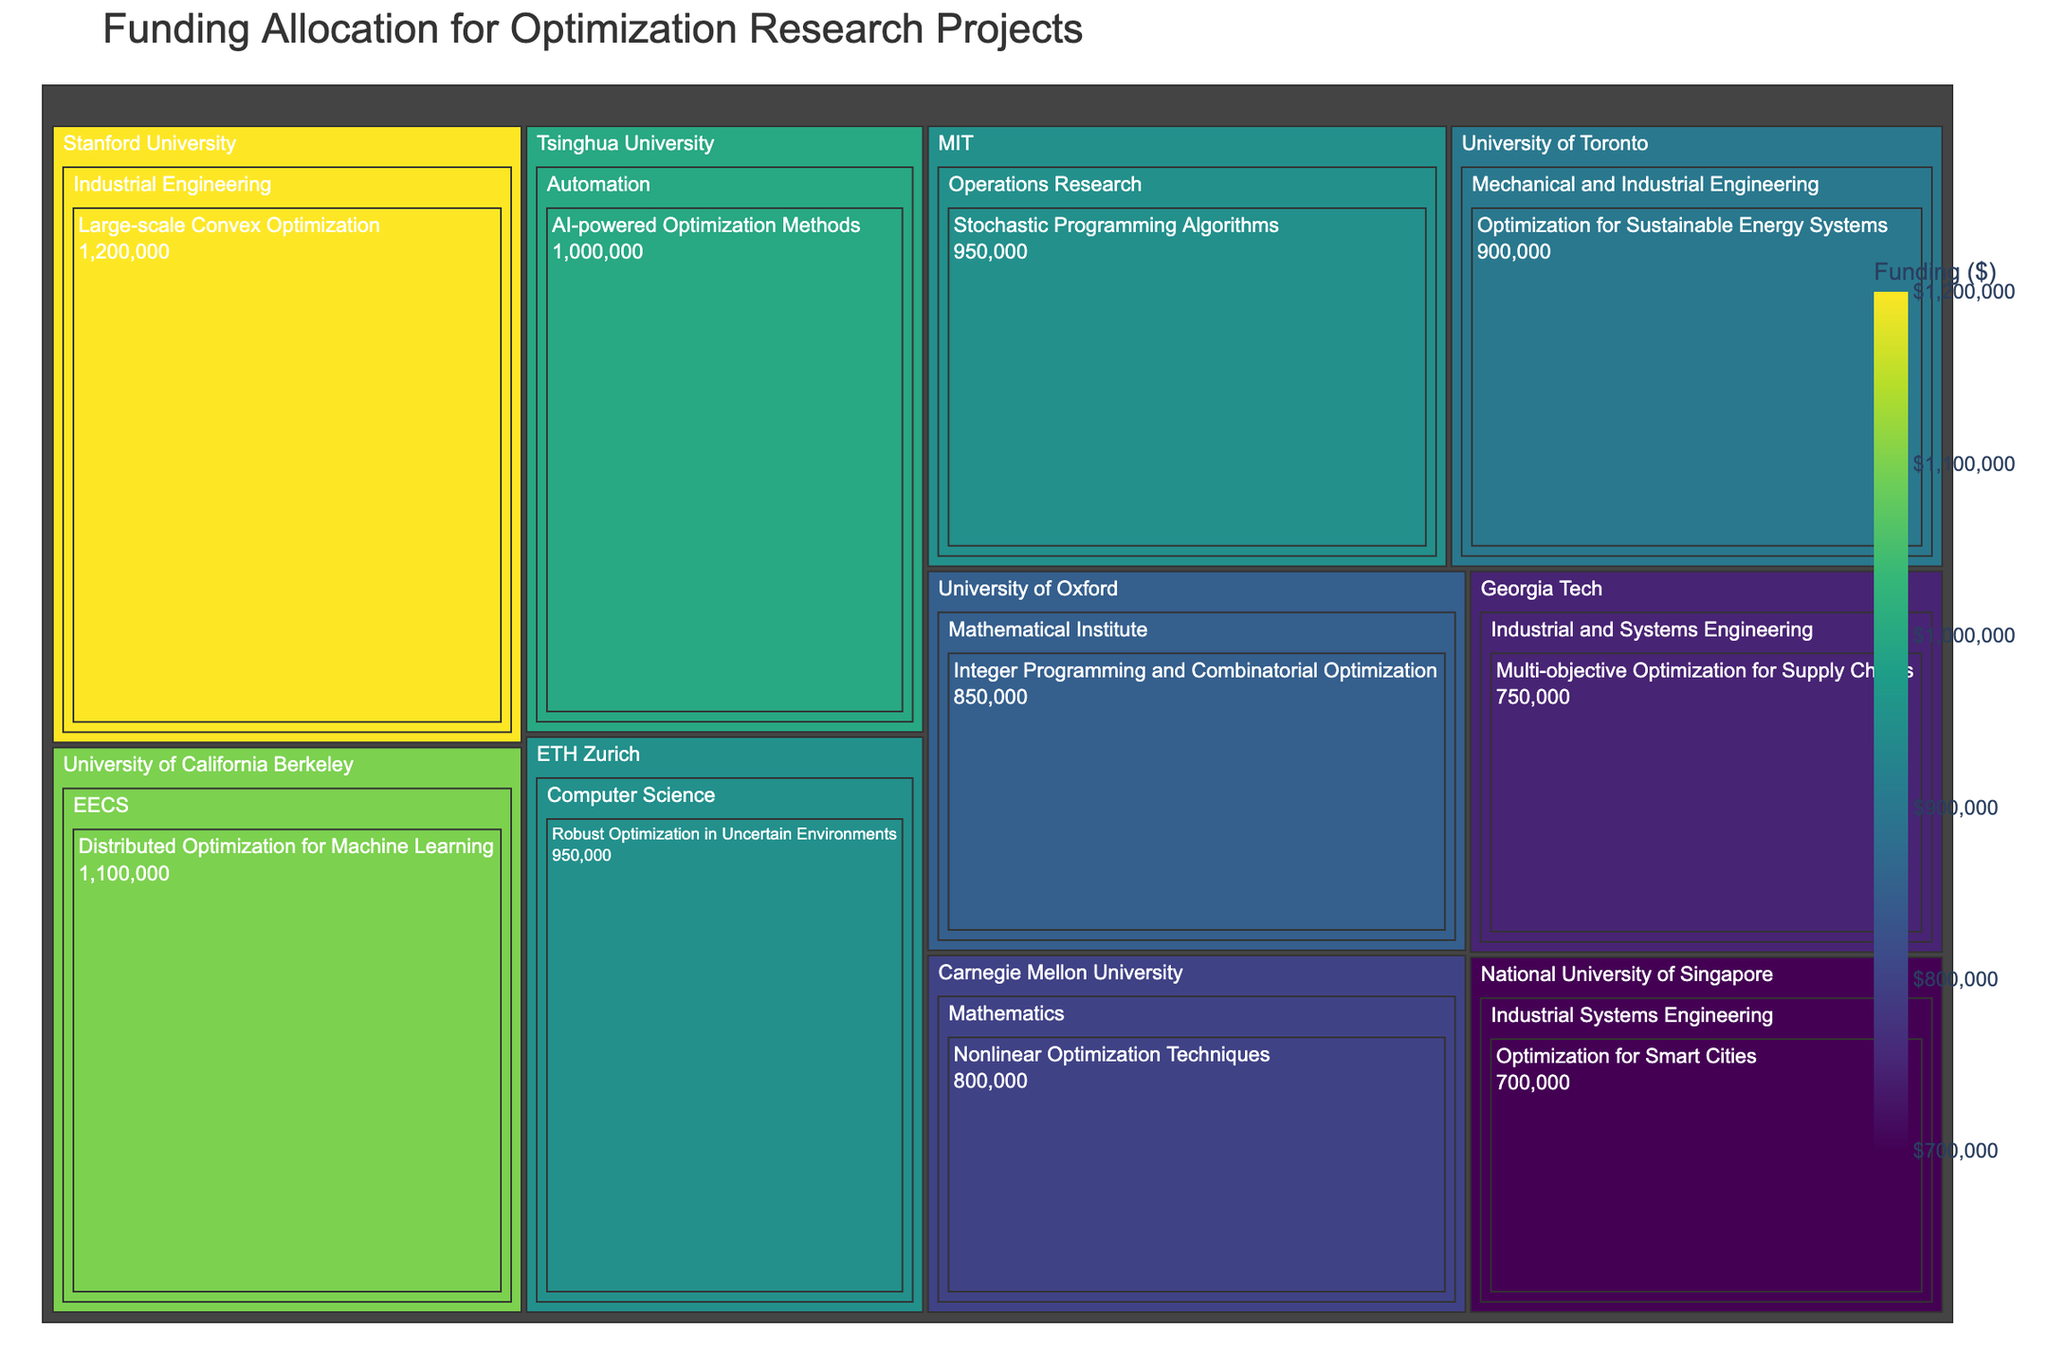What's the title of the figure? The title of the figure is usually prominently displayed at the top and provides a summary of the content. In this case, the title of the figure is "Funding Allocation for Optimization Research Projects".
Answer: Funding Allocation for Optimization Research Projects Which institution received the highest funding for its project? By observing the size and color intensity in the Treemap, we can see that Stanford University's "Large-scale Convex Optimization" project received the highest funding of $1,200,000, indicated by the largest and darkest section in the plot.
Answer: Stanford University What is the total funding allocated to the University of California Berkeley? To find the total funding for the University of California Berkeley, we look for the section labeled "University of California Berkeley" and sum up the funding amounts for its included projects. The only project listed is "Distributed Optimization for Machine Learning" with funding of $1,100,000.
Answer: $1,100,000 Which department at MIT has received funding, and for which project? The Treemap groups by institutions, then departments, followed by projects. At MIT, the department that received funding is "Operations Research" for the project "Stochastic Programming Algorithms".
Answer: Operations Research, Stochastic Programming Algorithms Compare the funding amounts between the institutions from Asia. To compare the funding amounts, we refer to the sections labeled for Asian institutions: National University of Singapore and Tsinghua University. The National University of Singapore received $700,000 for "Optimization for Smart Cities," whereas Tsinghua University received $1,000,000 for "AI-powered Optimization Methods". Tsinghua University received more funding.
Answer: Tsinghua University received more funding How does the funding for “Optimization for Sustainable Energy Systems” compare with “Optimization for Smart Cities”? To compare these two projects, we look at their corresponding sections in the Treemap. "Optimization for Sustainable Energy Systems" (University of Toronto) received $900,000, while "Optimization for Smart Cities" (National University of Singapore) received $700,000. Therefore, "Optimization for Sustainable Energy Systems" received more funding.
Answer: $900,000 vs. $700,000 What is the combined total funding for projects related to "Optimization for Machine Learning"? Searching the Treemap, the related project is "Distributed Optimization for Machine Learning" at University of California Berkeley with funding of $1,100,000. Since this is the only related project, the total funding is $1,100,000.
Answer: $1,100,000 Which project in the "Industrial and Systems Engineering" department at Georgia Tech received funding, and how much? In the Treemap, we locate the "Industrial and Systems Engineering" department at Georgia Tech and identify the project "Multi-objective Optimization for Supply Chains," which received $750,000.
Answer: Multi-objective Optimization for Supply Chains, $750,000 